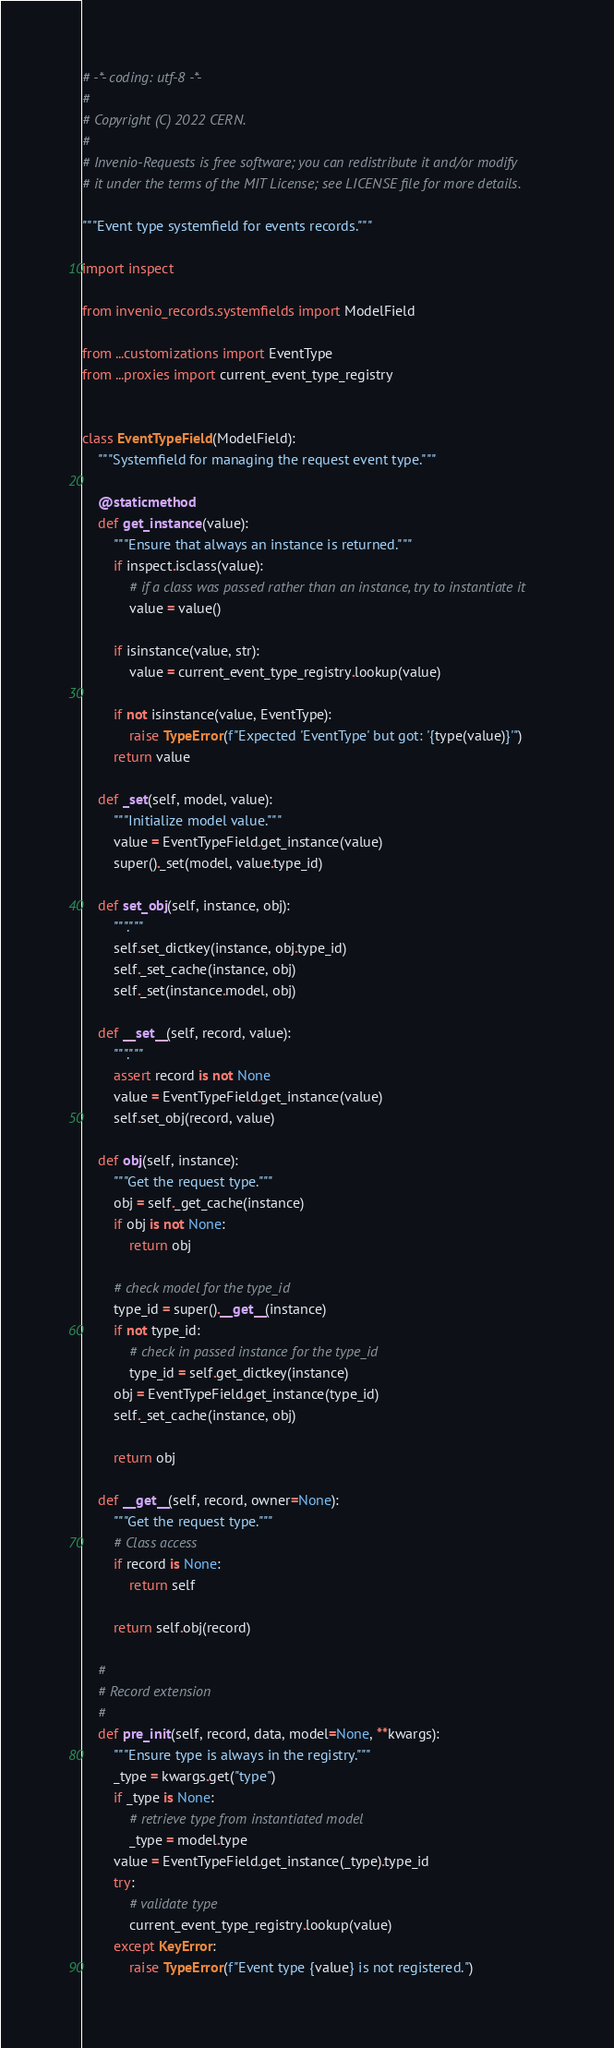<code> <loc_0><loc_0><loc_500><loc_500><_Python_># -*- coding: utf-8 -*-
#
# Copyright (C) 2022 CERN.
#
# Invenio-Requests is free software; you can redistribute it and/or modify
# it under the terms of the MIT License; see LICENSE file for more details.

"""Event type systemfield for events records."""

import inspect

from invenio_records.systemfields import ModelField

from ...customizations import EventType
from ...proxies import current_event_type_registry


class EventTypeField(ModelField):
    """Systemfield for managing the request event type."""

    @staticmethod
    def get_instance(value):
        """Ensure that always an instance is returned."""
        if inspect.isclass(value):
            # if a class was passed rather than an instance, try to instantiate it
            value = value()

        if isinstance(value, str):
            value = current_event_type_registry.lookup(value)

        if not isinstance(value, EventType):
            raise TypeError(f"Expected 'EventType' but got: '{type(value)}'")
        return value

    def _set(self, model, value):
        """Initialize model value."""
        value = EventTypeField.get_instance(value)
        super()._set(model, value.type_id)

    def set_obj(self, instance, obj):
        """."""
        self.set_dictkey(instance, obj.type_id)
        self._set_cache(instance, obj)
        self._set(instance.model, obj)

    def __set__(self, record, value):
        """."""
        assert record is not None
        value = EventTypeField.get_instance(value)
        self.set_obj(record, value)

    def obj(self, instance):
        """Get the request type."""
        obj = self._get_cache(instance)
        if obj is not None:
            return obj

        # check model for the type_id
        type_id = super().__get__(instance)
        if not type_id:
            # check in passed instance for the type_id
            type_id = self.get_dictkey(instance)
        obj = EventTypeField.get_instance(type_id)
        self._set_cache(instance, obj)

        return obj

    def __get__(self, record, owner=None):
        """Get the request type."""
        # Class access
        if record is None:
            return self

        return self.obj(record)

    #
    # Record extension
    #
    def pre_init(self, record, data, model=None, **kwargs):
        """Ensure type is always in the registry."""
        _type = kwargs.get("type")
        if _type is None:
            # retrieve type from instantiated model
            _type = model.type
        value = EventTypeField.get_instance(_type).type_id
        try:
            # validate type
            current_event_type_registry.lookup(value)
        except KeyError:
            raise TypeError(f"Event type {value} is not registered.")
</code> 